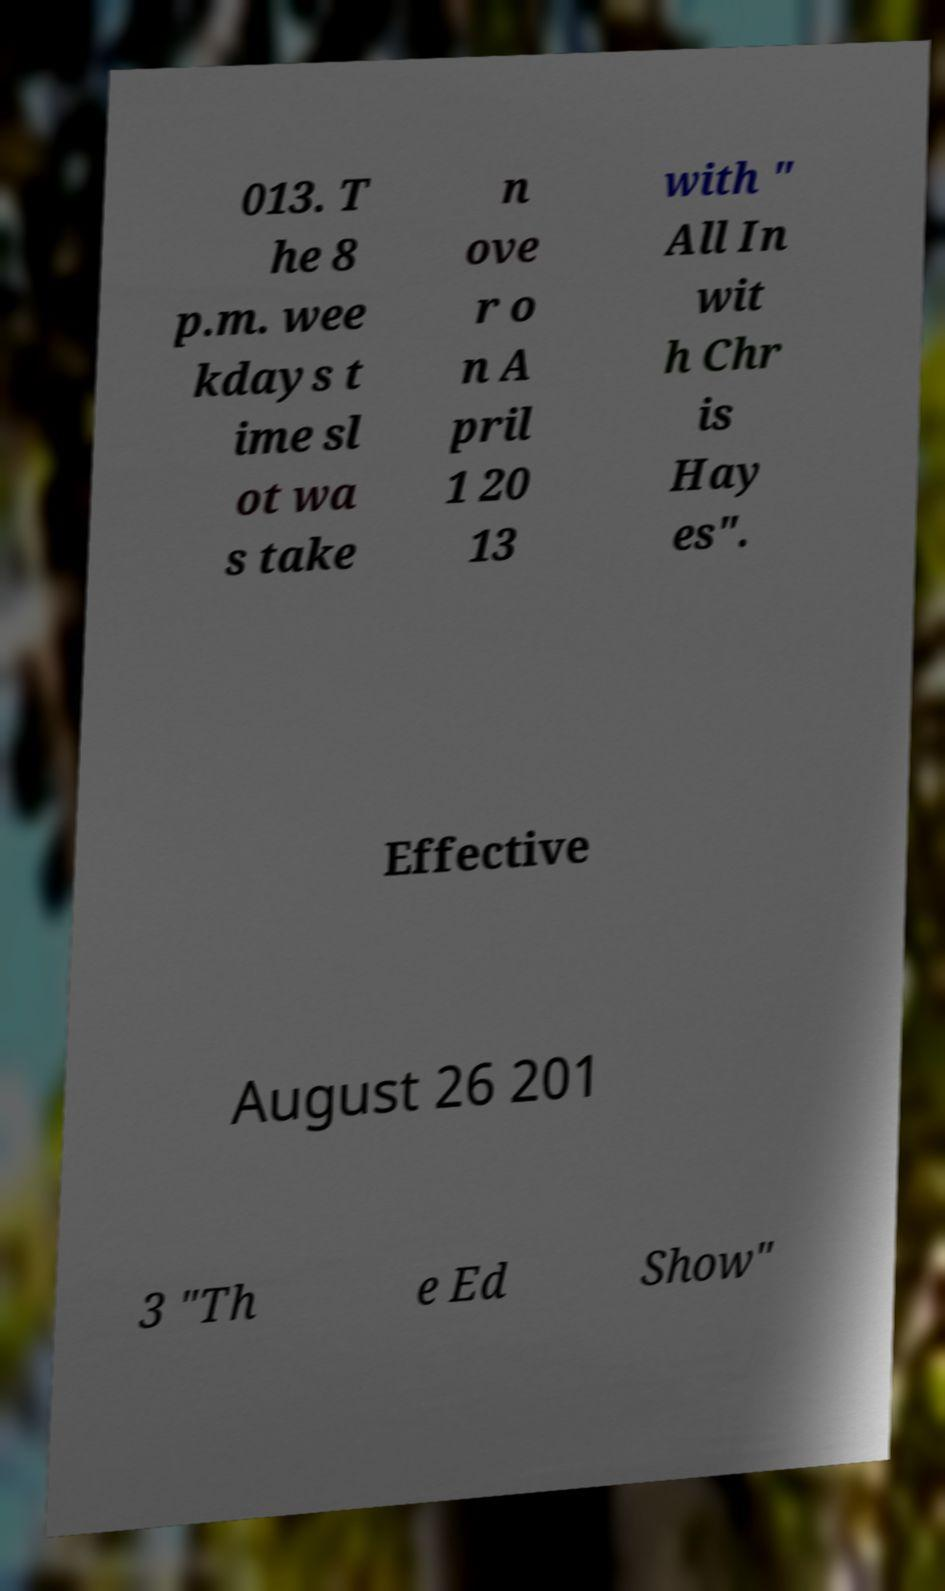Can you read and provide the text displayed in the image?This photo seems to have some interesting text. Can you extract and type it out for me? 013. T he 8 p.m. wee kdays t ime sl ot wa s take n ove r o n A pril 1 20 13 with " All In wit h Chr is Hay es". Effective August 26 201 3 "Th e Ed Show" 